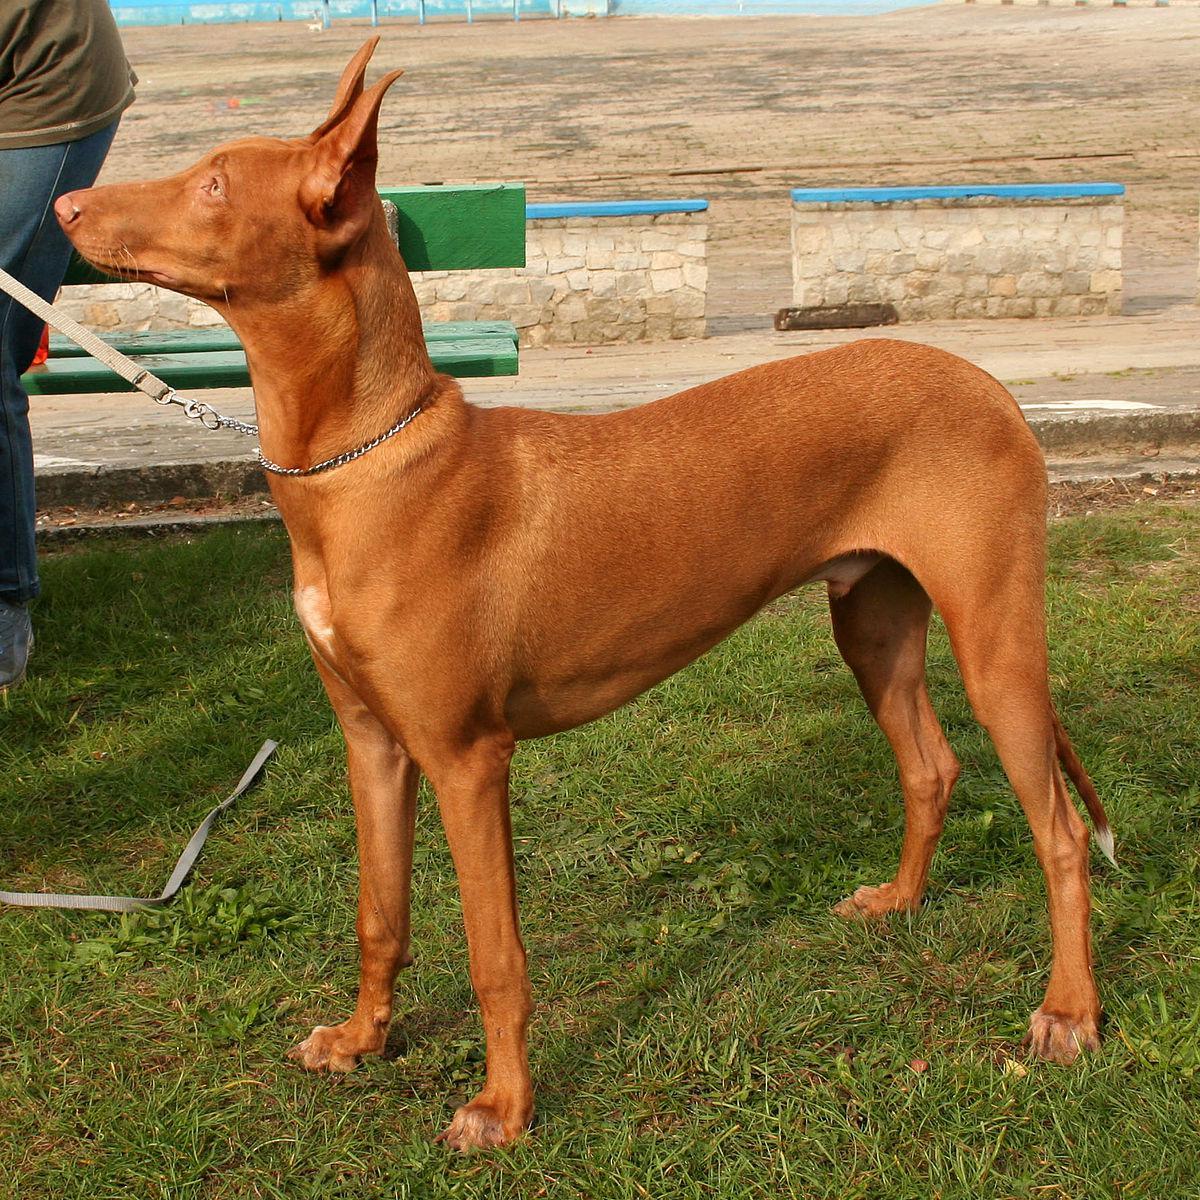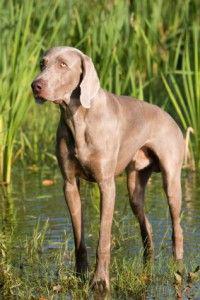The first image is the image on the left, the second image is the image on the right. Assess this claim about the two images: "The left image contains one dog facing towards the right.". Correct or not? Answer yes or no. No. 